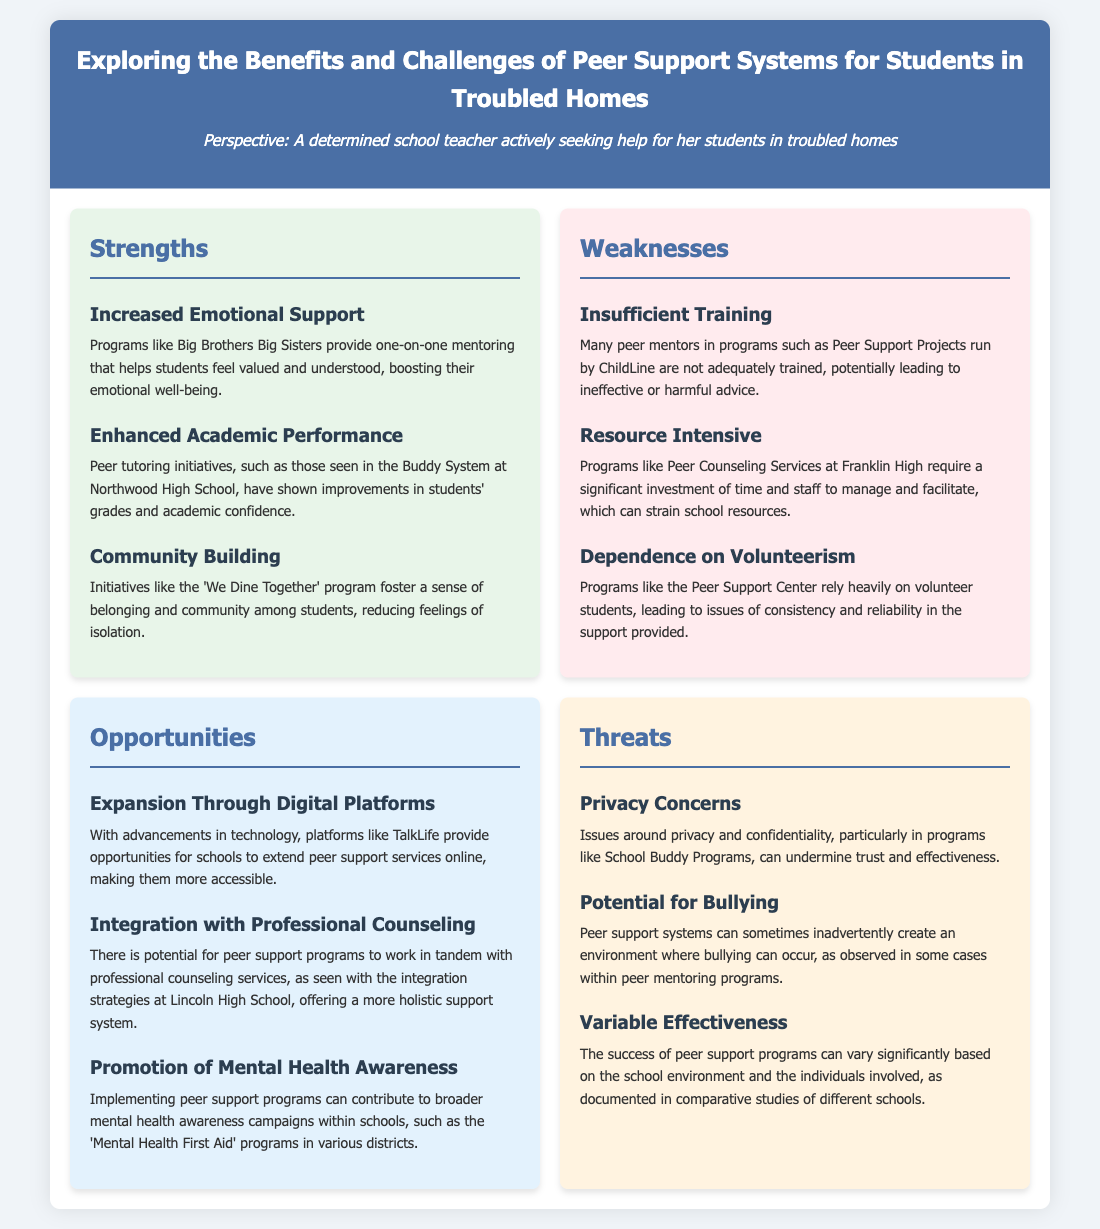What is one strength of peer support systems? The document lists "Increased Emotional Support" as a strength, highlighting the benefits of programs like Big Brothers Big Sisters.
Answer: Increased Emotional Support Which program is mentioned for enhancing academic performance? The document references the Buddy System at Northwood High School as an initiative that shows improvements in grades and academic confidence.
Answer: Buddy System What is a weakness related to peer mentor training? The document states that many peer mentors in programs like Peer Support Projects are not adequately trained.
Answer: Insufficient Training Name an opportunity for expansion mentioned in the document. The document mentions "Expansion Through Digital Platforms" as a significant opportunity for peer support programs.
Answer: Expansion Through Digital Platforms What threat is associated with privacy concerns? The document indicates that privacy concerns may undermine trust and effectiveness in programs like School Buddy Programs.
Answer: Privacy Concerns What is a potential issue that could arise within peer support systems? The document mentions "Potential for Bullying" as a concern in peer support systems.
Answer: Potential for Bullying How can peer support programs contribute to mental health awareness? The document states that implementing peer support programs can promote the broader mental health awareness campaigns.
Answer: Promotion of Mental Health Awareness What is a resource-related weakness of certain peer support programs? The document describes that programs like Peer Counseling Services require significant investment of time and staff to manage and facilitate.
Answer: Resource Intensive 